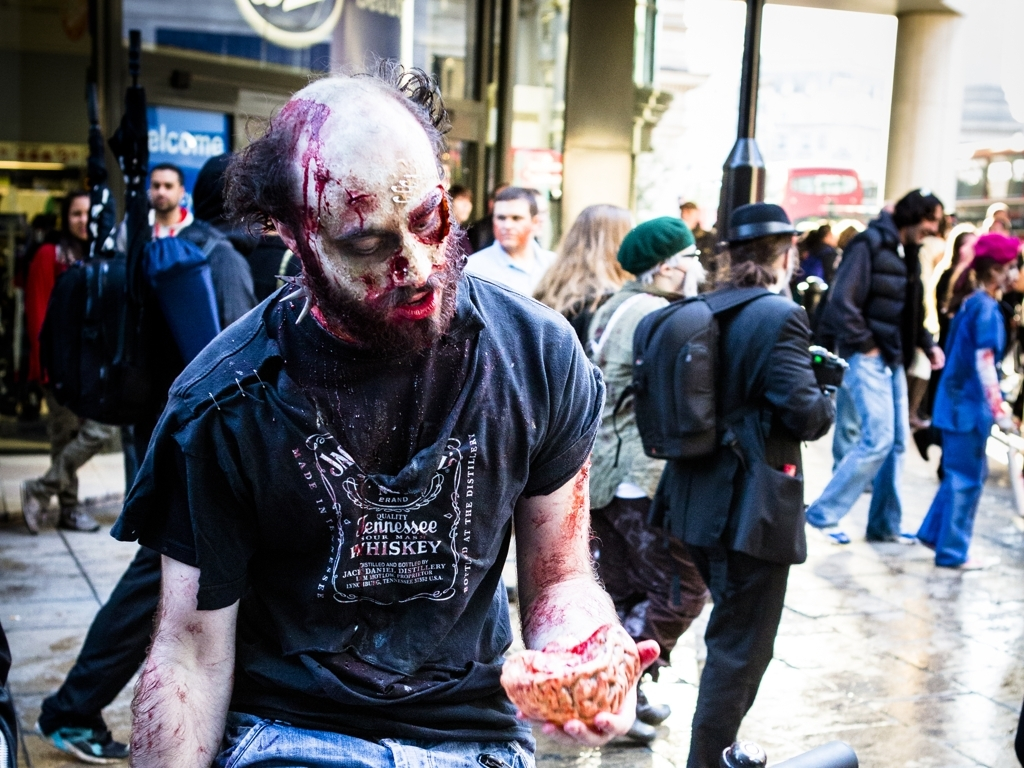How would you rate the overall quality of the photo?
A. Outstanding
B. Excellent
C. Acceptable
Answer with the option's letter from the given choices directly. While I rated the photo as 'C' for Acceptable, there is more to consider. The photo captures a dramatic moment with a person in intense zombie makeup, which suggests a Halloween event or a zombie walk. The image is in focus, with the subject clearly defined against a busy background, providing a strong contrast that holds the viewer's attention. However, the lighting appears to be harsh, likely from direct sunlight, and the composition seems haphazard with distracting elements in the background. These factors may detract from the photo's overall impact, which is why I find it to be acceptable rather than excellent or outstanding. 